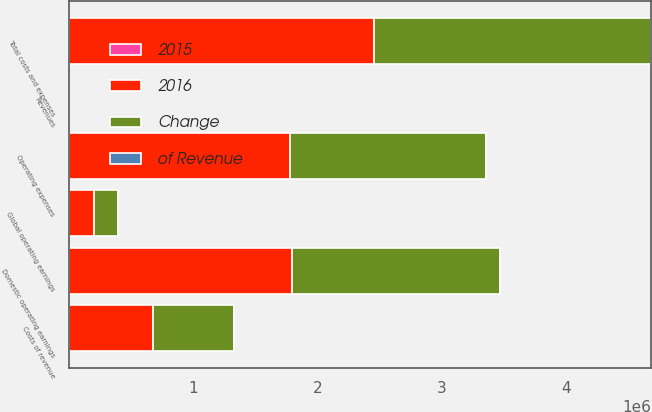Convert chart. <chart><loc_0><loc_0><loc_500><loc_500><stacked_bar_chart><ecel><fcel>Revenues<fcel>Costs of revenue<fcel>Operating expenses<fcel>Total costs and expenses<fcel>Domestic operating earnings<fcel>Global operating earnings<nl><fcel>2016<fcel>79<fcel>676437<fcel>1.77415e+06<fcel>2.45058e+06<fcel>1.79451e+06<fcel>202454<nl><fcel>2015<fcel>100<fcel>16<fcel>42<fcel>58<fcel>42<fcel>37<nl><fcel>Change<fcel>79<fcel>651826<fcel>1.57759e+06<fcel>2.22942e+06<fcel>1.67503e+06<fcel>188811<nl><fcel>of Revenue<fcel>9<fcel>4<fcel>12<fcel>10<fcel>7<fcel>7<nl></chart> 